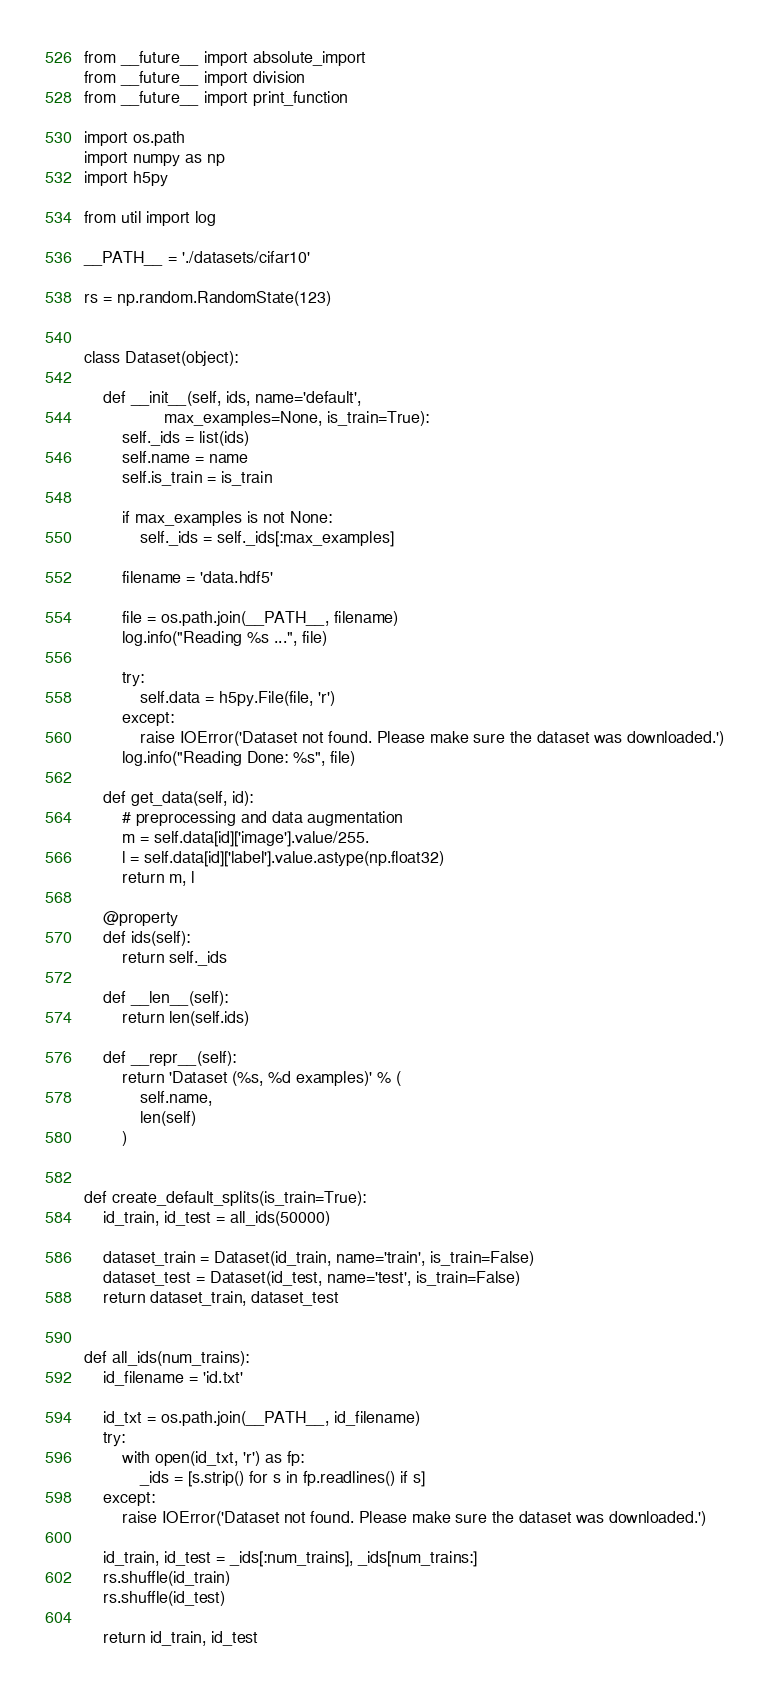<code> <loc_0><loc_0><loc_500><loc_500><_Python_>from __future__ import absolute_import
from __future__ import division
from __future__ import print_function

import os.path
import numpy as np
import h5py

from util import log

__PATH__ = './datasets/cifar10'

rs = np.random.RandomState(123)


class Dataset(object):

    def __init__(self, ids, name='default',
                 max_examples=None, is_train=True):
        self._ids = list(ids)
        self.name = name
        self.is_train = is_train

        if max_examples is not None:
            self._ids = self._ids[:max_examples]

        filename = 'data.hdf5'

        file = os.path.join(__PATH__, filename)
        log.info("Reading %s ...", file)

        try:
            self.data = h5py.File(file, 'r')
        except:
            raise IOError('Dataset not found. Please make sure the dataset was downloaded.')
        log.info("Reading Done: %s", file)

    def get_data(self, id):
        # preprocessing and data augmentation
        m = self.data[id]['image'].value/255.
        l = self.data[id]['label'].value.astype(np.float32)
        return m, l

    @property
    def ids(self):
        return self._ids

    def __len__(self):
        return len(self.ids)

    def __repr__(self):
        return 'Dataset (%s, %d examples)' % (
            self.name,
            len(self)
        )


def create_default_splits(is_train=True):
    id_train, id_test = all_ids(50000)

    dataset_train = Dataset(id_train, name='train', is_train=False)
    dataset_test = Dataset(id_test, name='test', is_train=False)
    return dataset_train, dataset_test


def all_ids(num_trains):
    id_filename = 'id.txt'

    id_txt = os.path.join(__PATH__, id_filename)
    try:
        with open(id_txt, 'r') as fp:
            _ids = [s.strip() for s in fp.readlines() if s]
    except:
        raise IOError('Dataset not found. Please make sure the dataset was downloaded.')

    id_train, id_test = _ids[:num_trains], _ids[num_trains:]
    rs.shuffle(id_train)
    rs.shuffle(id_test)

    return id_train, id_test
</code> 